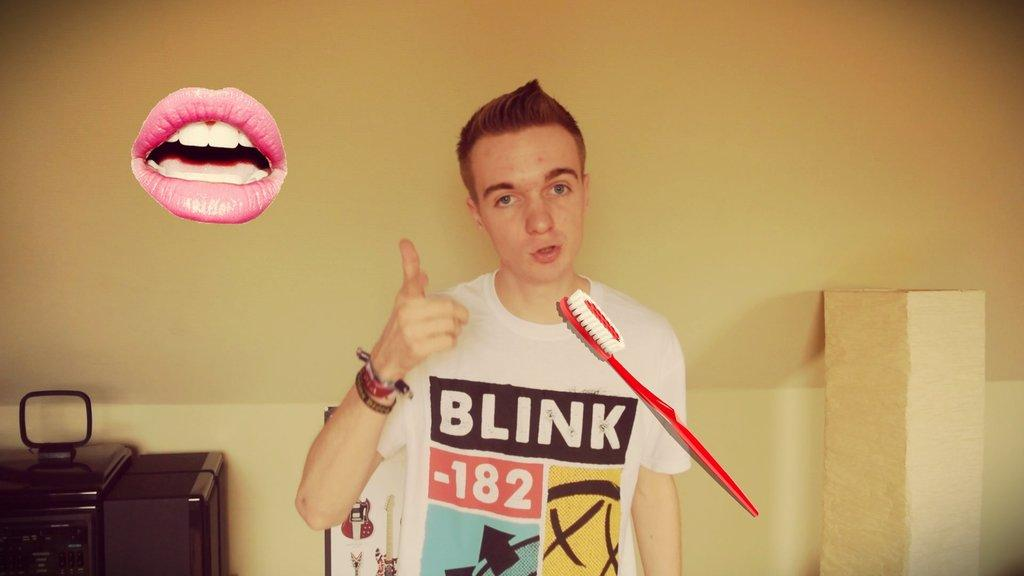<image>
Give a short and clear explanation of the subsequent image. a boy wearing a white shirt that says 'blink 182' on it 